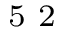<formula> <loc_0><loc_0><loc_500><loc_500>^ { 5 } 2</formula> 